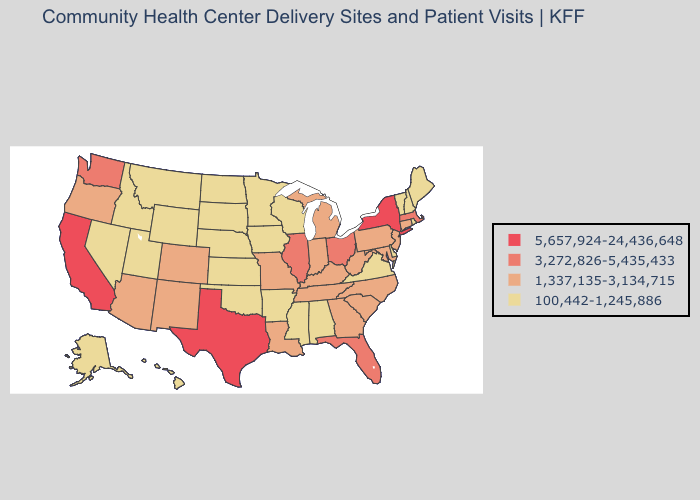Does Tennessee have a higher value than Washington?
Short answer required. No. Does Indiana have the same value as Alabama?
Answer briefly. No. What is the highest value in states that border Maine?
Short answer required. 100,442-1,245,886. Does Nebraska have the highest value in the USA?
Give a very brief answer. No. Does Delaware have a lower value than Rhode Island?
Give a very brief answer. No. Name the states that have a value in the range 100,442-1,245,886?
Short answer required. Alabama, Alaska, Arkansas, Delaware, Hawaii, Idaho, Iowa, Kansas, Maine, Minnesota, Mississippi, Montana, Nebraska, Nevada, New Hampshire, North Dakota, Oklahoma, Rhode Island, South Dakota, Utah, Vermont, Virginia, Wisconsin, Wyoming. Name the states that have a value in the range 1,337,135-3,134,715?
Be succinct. Arizona, Colorado, Connecticut, Georgia, Indiana, Kentucky, Louisiana, Maryland, Michigan, Missouri, New Jersey, New Mexico, North Carolina, Oregon, Pennsylvania, South Carolina, Tennessee, West Virginia. Does West Virginia have a higher value than Iowa?
Answer briefly. Yes. What is the value of Alabama?
Quick response, please. 100,442-1,245,886. Does Nevada have the same value as West Virginia?
Quick response, please. No. Name the states that have a value in the range 100,442-1,245,886?
Give a very brief answer. Alabama, Alaska, Arkansas, Delaware, Hawaii, Idaho, Iowa, Kansas, Maine, Minnesota, Mississippi, Montana, Nebraska, Nevada, New Hampshire, North Dakota, Oklahoma, Rhode Island, South Dakota, Utah, Vermont, Virginia, Wisconsin, Wyoming. What is the value of New Jersey?
Be succinct. 1,337,135-3,134,715. Is the legend a continuous bar?
Answer briefly. No. Name the states that have a value in the range 100,442-1,245,886?
Short answer required. Alabama, Alaska, Arkansas, Delaware, Hawaii, Idaho, Iowa, Kansas, Maine, Minnesota, Mississippi, Montana, Nebraska, Nevada, New Hampshire, North Dakota, Oklahoma, Rhode Island, South Dakota, Utah, Vermont, Virginia, Wisconsin, Wyoming. Does Delaware have the lowest value in the USA?
Answer briefly. Yes. 